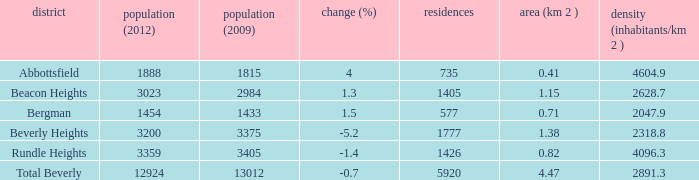How many Dwellings does Beverly Heights have that have a change percent larger than -5.2? None. 